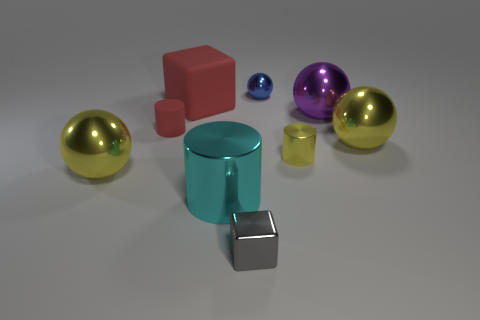Subtract all metallic cylinders. How many cylinders are left? 1 Subtract all blue balls. How many balls are left? 3 Add 1 big cyan metal cylinders. How many objects exist? 10 Subtract all green spheres. Subtract all cyan blocks. How many spheres are left? 4 Subtract all balls. How many objects are left? 5 Add 7 brown matte cylinders. How many brown matte cylinders exist? 7 Subtract 0 purple cylinders. How many objects are left? 9 Subtract all big red cylinders. Subtract all tiny rubber cylinders. How many objects are left? 8 Add 1 yellow metal cylinders. How many yellow metal cylinders are left? 2 